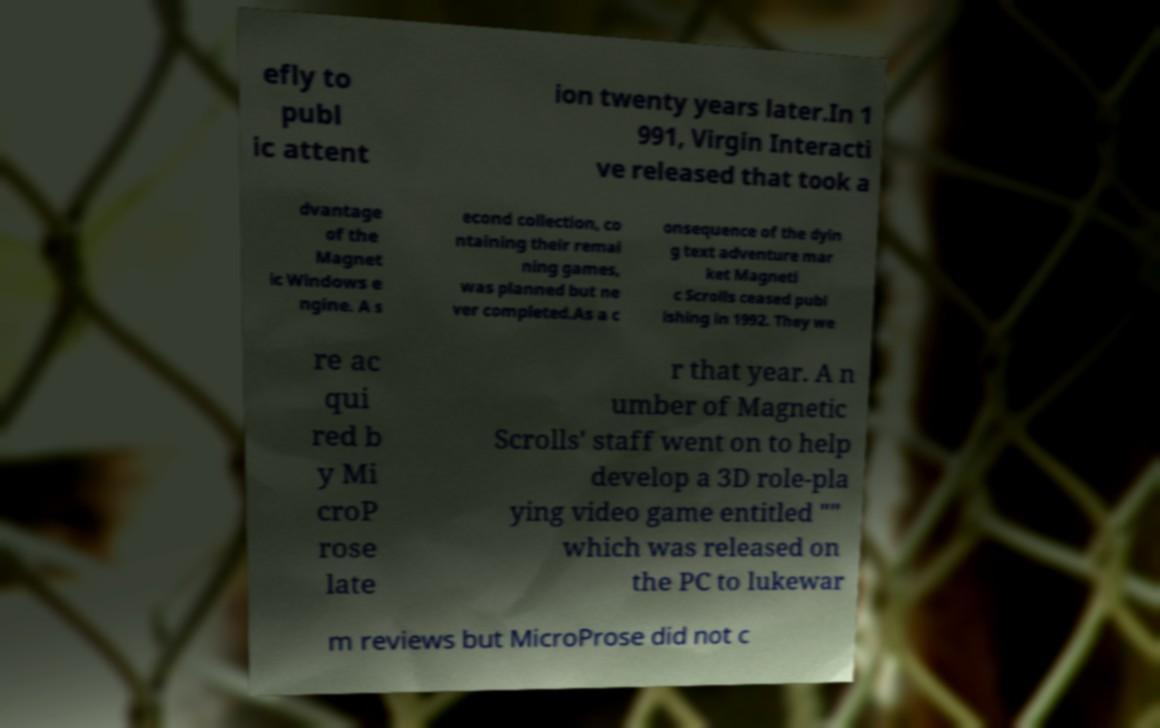Could you extract and type out the text from this image? efly to publ ic attent ion twenty years later.In 1 991, Virgin Interacti ve released that took a dvantage of the Magnet ic Windows e ngine. A s econd collection, co ntaining their remai ning games, was planned but ne ver completed.As a c onsequence of the dyin g text adventure mar ket Magneti c Scrolls ceased publ ishing in 1992. They we re ac qui red b y Mi croP rose late r that year. A n umber of Magnetic Scrolls' staff went on to help develop a 3D role-pla ying video game entitled "" which was released on the PC to lukewar m reviews but MicroProse did not c 